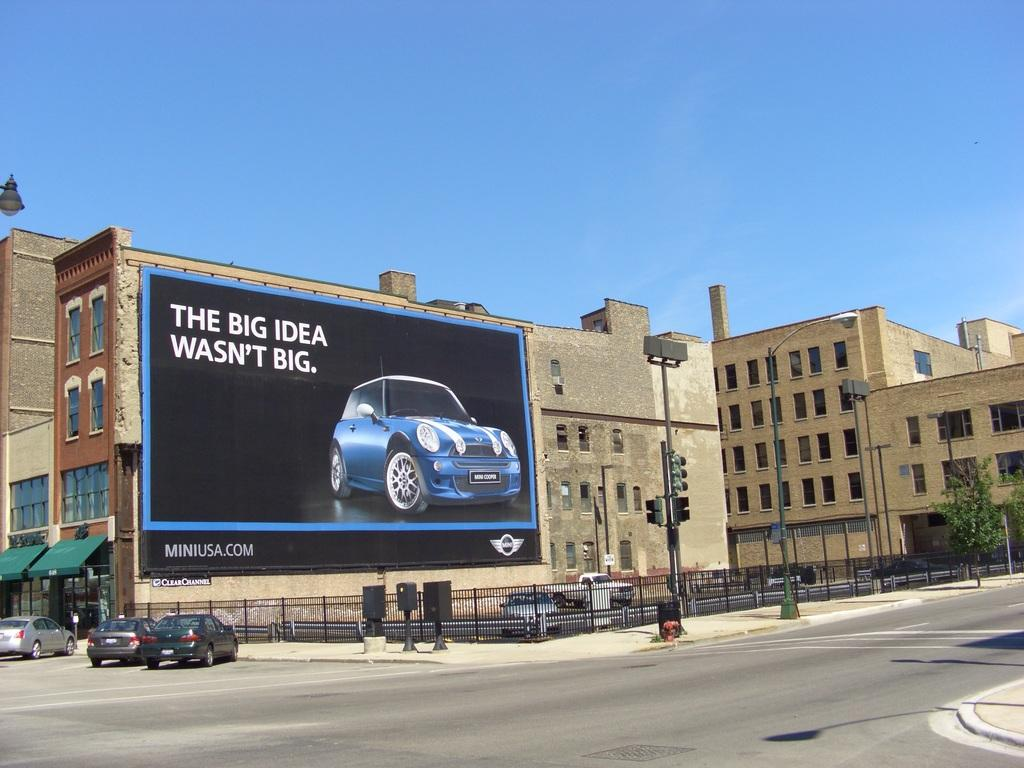<image>
Provide a brief description of the given image. A large billboard for Mini Cooper hangs in front of a building. 